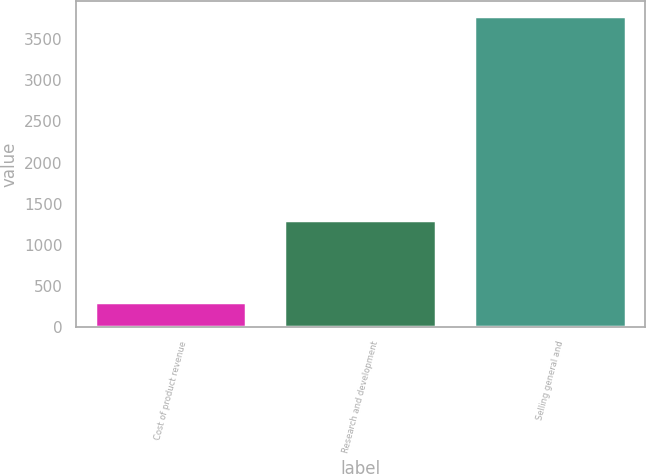Convert chart to OTSL. <chart><loc_0><loc_0><loc_500><loc_500><bar_chart><fcel>Cost of product revenue<fcel>Research and development<fcel>Selling general and<nl><fcel>301<fcel>1297<fcel>3778<nl></chart> 